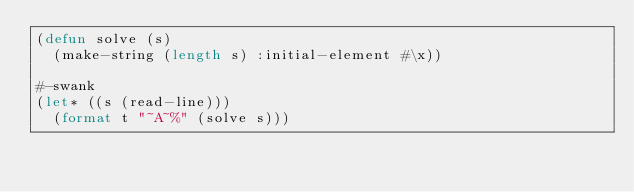<code> <loc_0><loc_0><loc_500><loc_500><_Lisp_>(defun solve (s)
  (make-string (length s) :initial-element #\x))

#-swank
(let* ((s (read-line)))
  (format t "~A~%" (solve s)))
</code> 